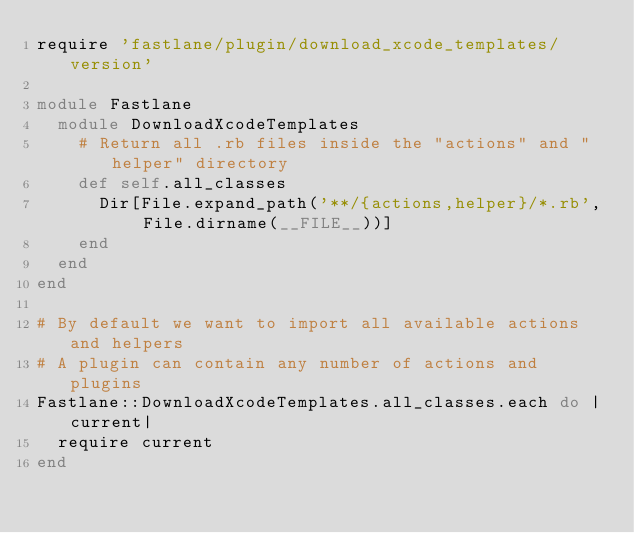Convert code to text. <code><loc_0><loc_0><loc_500><loc_500><_Ruby_>require 'fastlane/plugin/download_xcode_templates/version'

module Fastlane
  module DownloadXcodeTemplates
    # Return all .rb files inside the "actions" and "helper" directory
    def self.all_classes
      Dir[File.expand_path('**/{actions,helper}/*.rb', File.dirname(__FILE__))]
    end
  end
end

# By default we want to import all available actions and helpers
# A plugin can contain any number of actions and plugins
Fastlane::DownloadXcodeTemplates.all_classes.each do |current|
  require current
end
</code> 